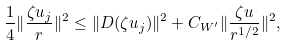<formula> <loc_0><loc_0><loc_500><loc_500>\frac { 1 } { 4 } \| \frac { \zeta u _ { j } } { r } \| ^ { 2 } \leq \| D ( \zeta u _ { j } ) \| ^ { 2 } + C _ { W ^ { \prime } } \| \frac { \zeta u } { r ^ { 1 / 2 } } \| ^ { 2 } ,</formula> 